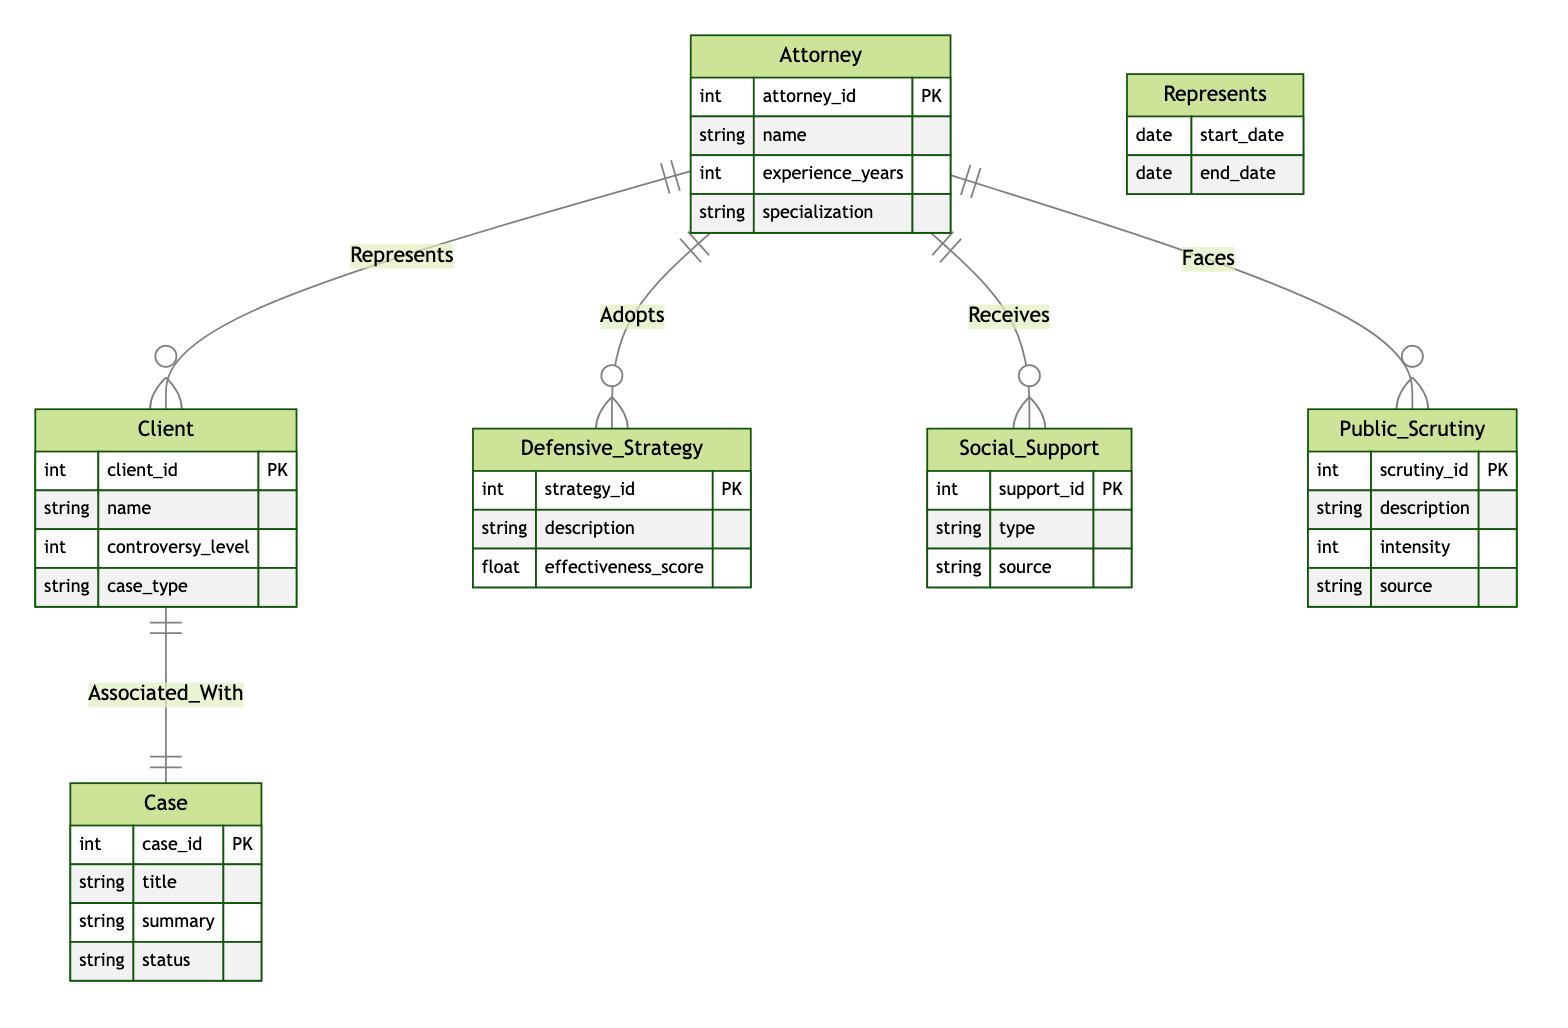What is the primary relationship between Attorney and Client? The primary relationship between Attorney and Client is labeled "Represents". This indicates that an Attorney represents a Client in legal matters as depicted by the connecting line between these two entities.
Answer: Represents How many entities are present in the diagram? The diagram includes five entities: Attorney, Client, Defensive Strategy, Social Support, Public Scrutiny, and Case. By counting these nodes, we find a total of six entities.
Answer: Six What attribute is associated with the Public Scrutiny entity? The Public Scrutiny entity has several attributes, including description, intensity, and source. We can refer to the attributes listed under the Public Scrutiny node to identify them.
Answer: Description, Intensity, Source Which entity is associated with the Case entity? The Case entity is associated with the Client entity as indicated by the "Associated_With" relationship. The arrows connecting these two entities denote their relationship in the context of the diagram.
Answer: Client What does the Attorney receive in the diagram? The Attorney receives Social Support as illustrated by the "Receives" relationship connecting Attorney to Social Support. This indicates a flow of support towards the Attorney from various sources.
Answer: Social Support How are Defensive Strategies linked to Attorneys? Defensive Strategies are linked to Attorneys through the "Adopts" relationship. This signifies that an Attorney adopts a specific defensive strategy for their legal representation.
Answer: Adopts What is the significance of the start_date and end_date in the Represents relationship? The start_date and end_date attributes in the Represents relationship indicate the duration of time an Attorney is representing a Client. These attributes help in understanding the timeline of legal representation.
Answer: Duration How many types of relationships exist between Attorney and other entities? There are four types of relationships that exist between Attorney and other entities: Represents (with Client), Adopts (with Defensive Strategy), Receives (with Social Support), and Faces (with Public Scrutiny). Each relationship defines a specific interaction in the context of defending clients.
Answer: Four What is the intensity attribute associated with? The intensity attribute is associated with the Public Scrutiny entity. This attribute represents the degree of scrutiny faced by an Attorney while defending a controversial client, as indicated in the diagram.
Answer: Public Scrutiny 